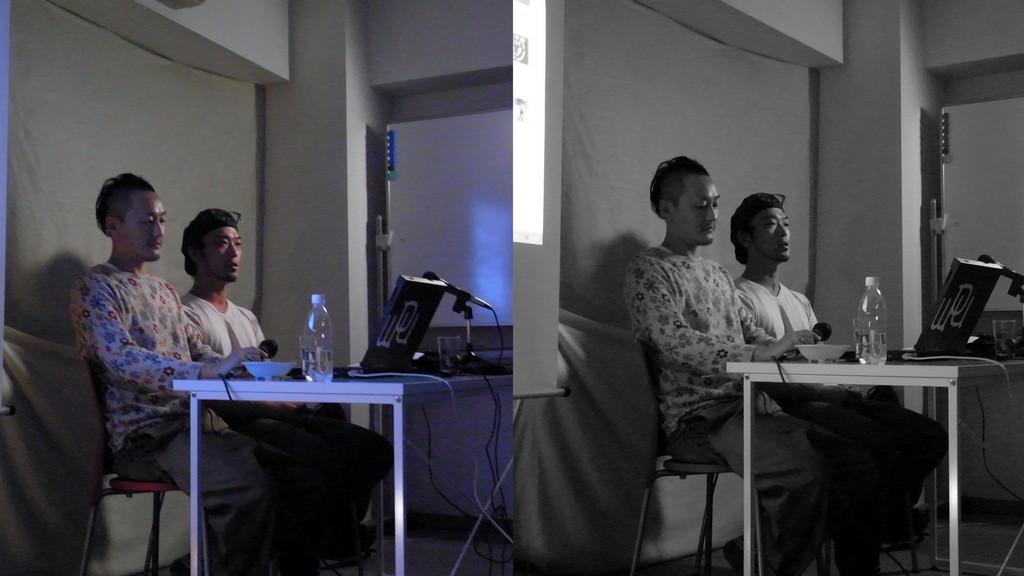How many people are sitting on the chair in the image? There are two persons sitting on a chair in the image. What is present in the image besides the chair and the people? There is a table in the image. What can be seen on the table? There is a system (possibly a computer or electronic device) and a water bottle on the table. What type of shirt is being used as fuel for the system in the image? There is no shirt or fuel present in the image; it features two persons sitting on a chair, a table, a system, and a water bottle. 